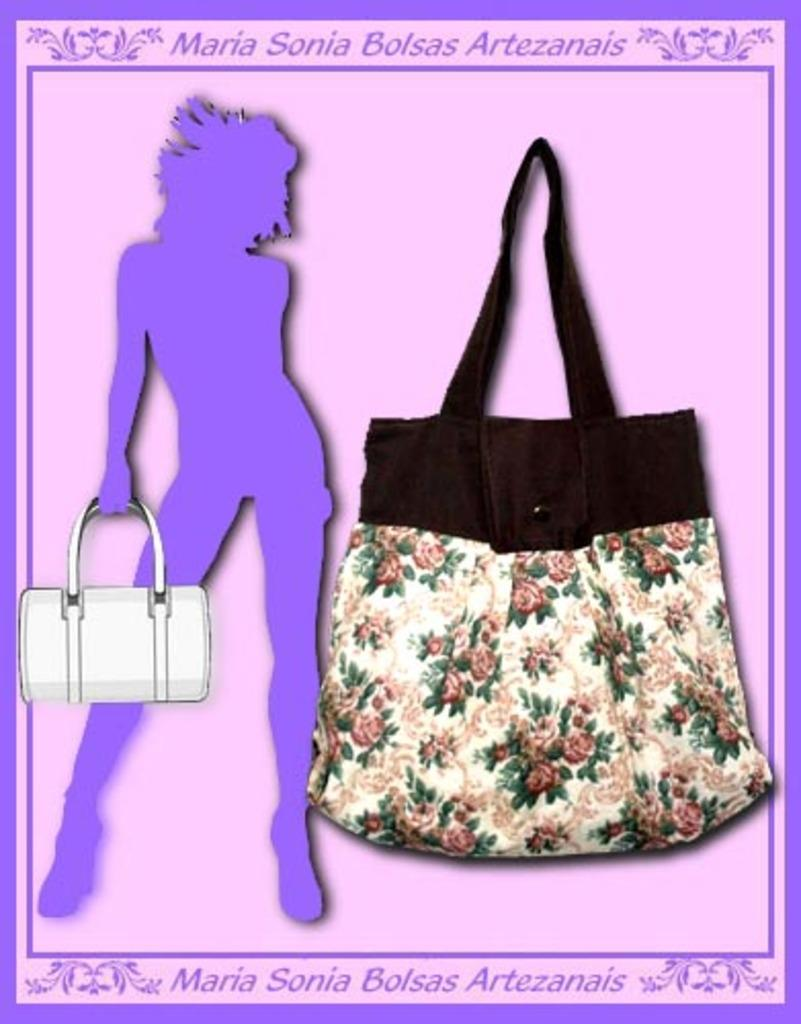What type of bag is visible in the image? There is a bag in white with a floral design in the image. Where is the bag located in the image? The bag is hanged on a pink wall. What else can be seen in the image besides the bag? There is a poster of a lady holding a bag in the image. How many jars of jelly can be seen on the pink wall in the image? There are no jars of jelly visible on the pink wall in the image. What type of car is parked next to the pink wall in the image? There is no car present in the image. 